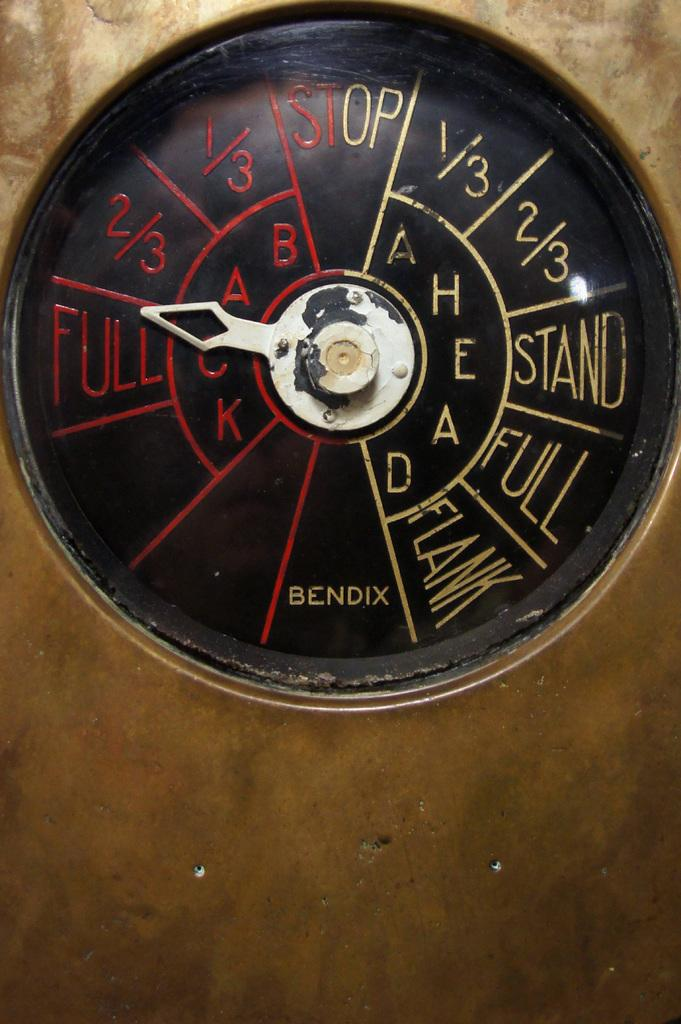<image>
Write a terse but informative summary of the picture. Circular black object with the word BENDIX on the bottom. 